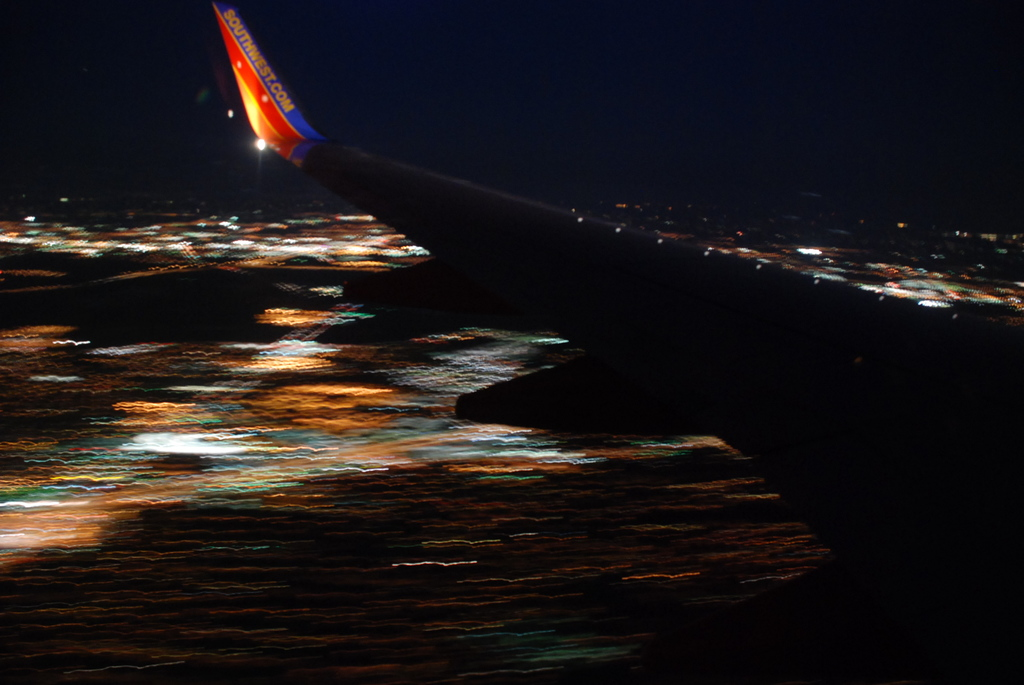Can you guess the phase of the flight based on this image? Considering the angle of the wing and the altitude suggesting proximity to the city lights, it's plausible that the aircraft is in the landing phase of the flight, preparing to touch down at the nearby airport. 